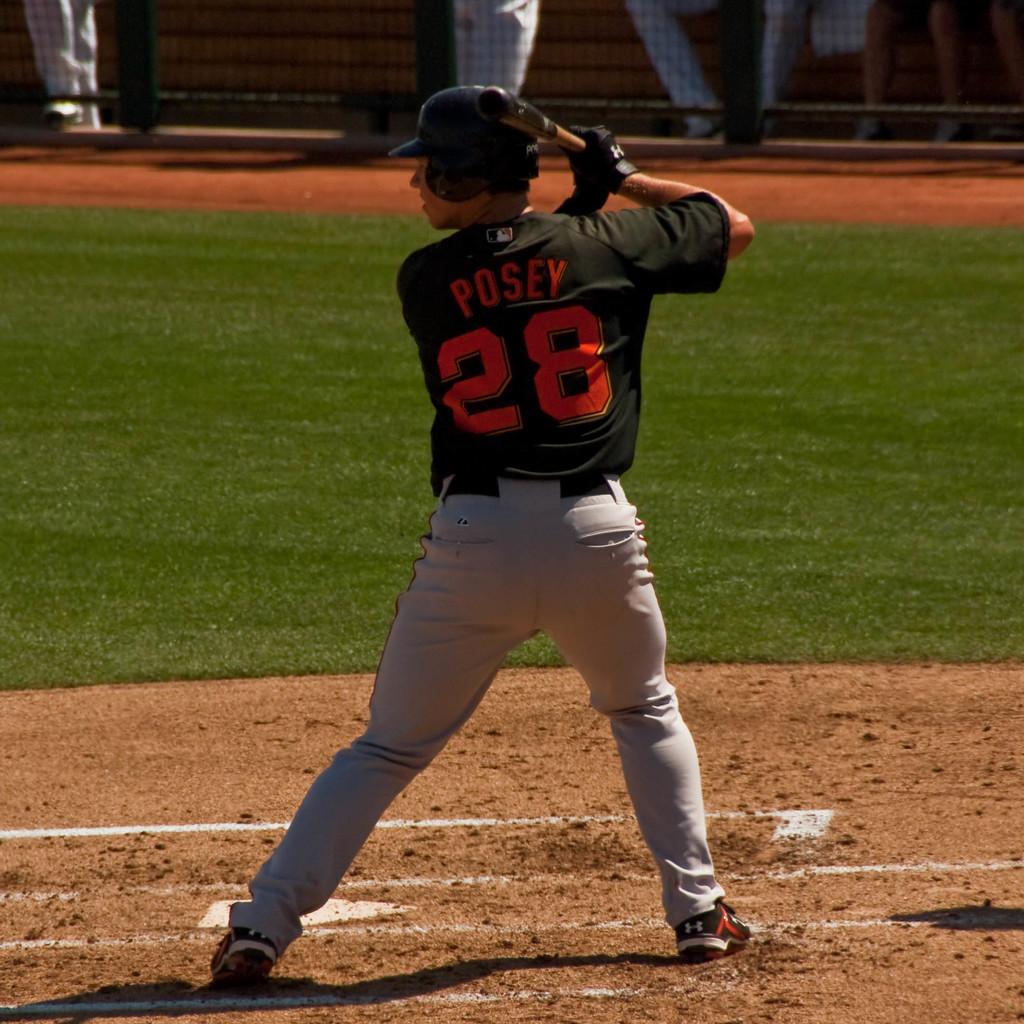What is the name on the jersey?
Provide a short and direct response. Posey. 